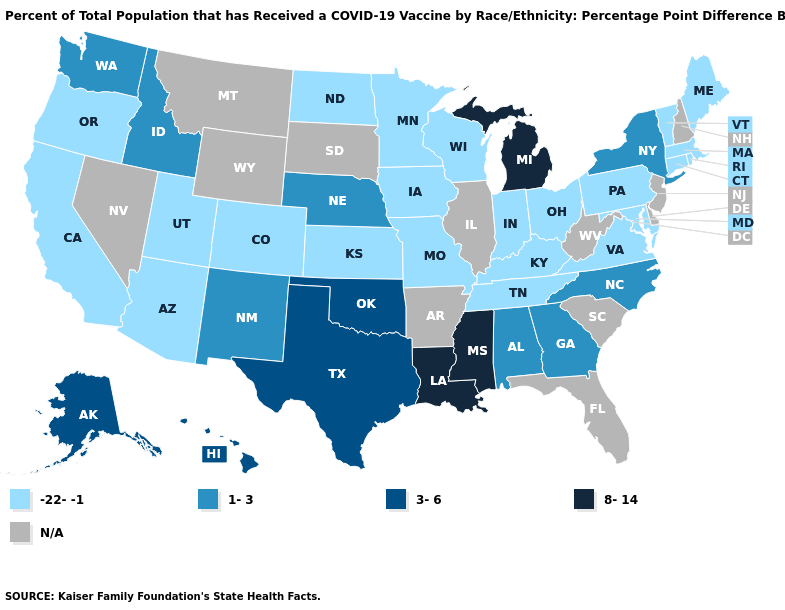What is the lowest value in states that border New Jersey?
Be succinct. -22--1. What is the highest value in states that border Florida?
Short answer required. 1-3. What is the lowest value in the South?
Short answer required. -22--1. Does Tennessee have the highest value in the South?
Keep it brief. No. Does New Mexico have the lowest value in the West?
Concise answer only. No. Among the states that border Texas , does Louisiana have the highest value?
Be succinct. Yes. What is the highest value in the USA?
Concise answer only. 8-14. What is the value of Montana?
Answer briefly. N/A. Name the states that have a value in the range 8-14?
Quick response, please. Louisiana, Michigan, Mississippi. Name the states that have a value in the range 1-3?
Short answer required. Alabama, Georgia, Idaho, Nebraska, New Mexico, New York, North Carolina, Washington. What is the lowest value in the West?
Quick response, please. -22--1. What is the value of New York?
Concise answer only. 1-3. Among the states that border Wisconsin , does Michigan have the highest value?
Give a very brief answer. Yes. Which states have the highest value in the USA?
Answer briefly. Louisiana, Michigan, Mississippi. What is the value of Idaho?
Give a very brief answer. 1-3. 